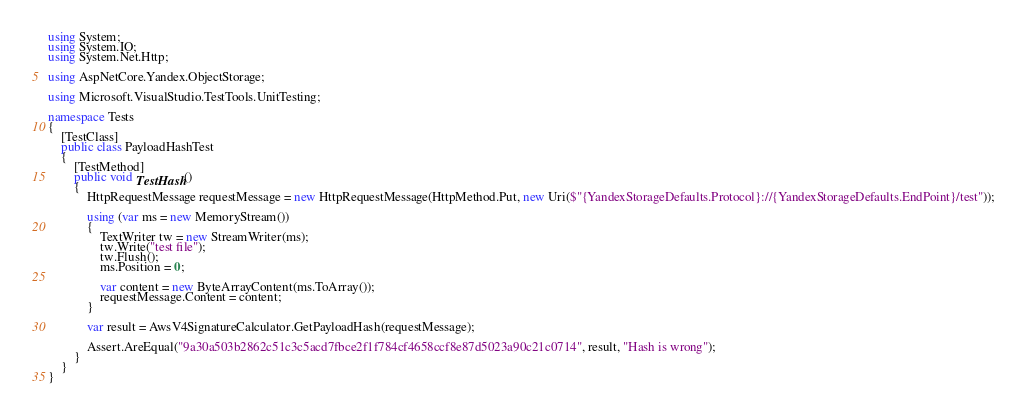Convert code to text. <code><loc_0><loc_0><loc_500><loc_500><_C#_>using System;
using System.IO;
using System.Net.Http;

using AspNetCore.Yandex.ObjectStorage;

using Microsoft.VisualStudio.TestTools.UnitTesting;

namespace Tests
{
	[TestClass]
	public class PayloadHashTest
	{
		[TestMethod]
		public void TestHash()
		{
			HttpRequestMessage requestMessage = new HttpRequestMessage(HttpMethod.Put, new Uri($"{YandexStorageDefaults.Protocol}://{YandexStorageDefaults.EndPoint}/test"));

			using (var ms = new MemoryStream())
			{
				TextWriter tw = new StreamWriter(ms);
				tw.Write("test file");
				tw.Flush();
				ms.Position = 0;

				var content = new ByteArrayContent(ms.ToArray());
				requestMessage.Content = content;
			}

			var result = AwsV4SignatureCalculator.GetPayloadHash(requestMessage);

			Assert.AreEqual("9a30a503b2862c51c3c5acd7fbce2f1f784cf4658ccf8e87d5023a90c21c0714", result, "Hash is wrong");
		}
	}
}</code> 